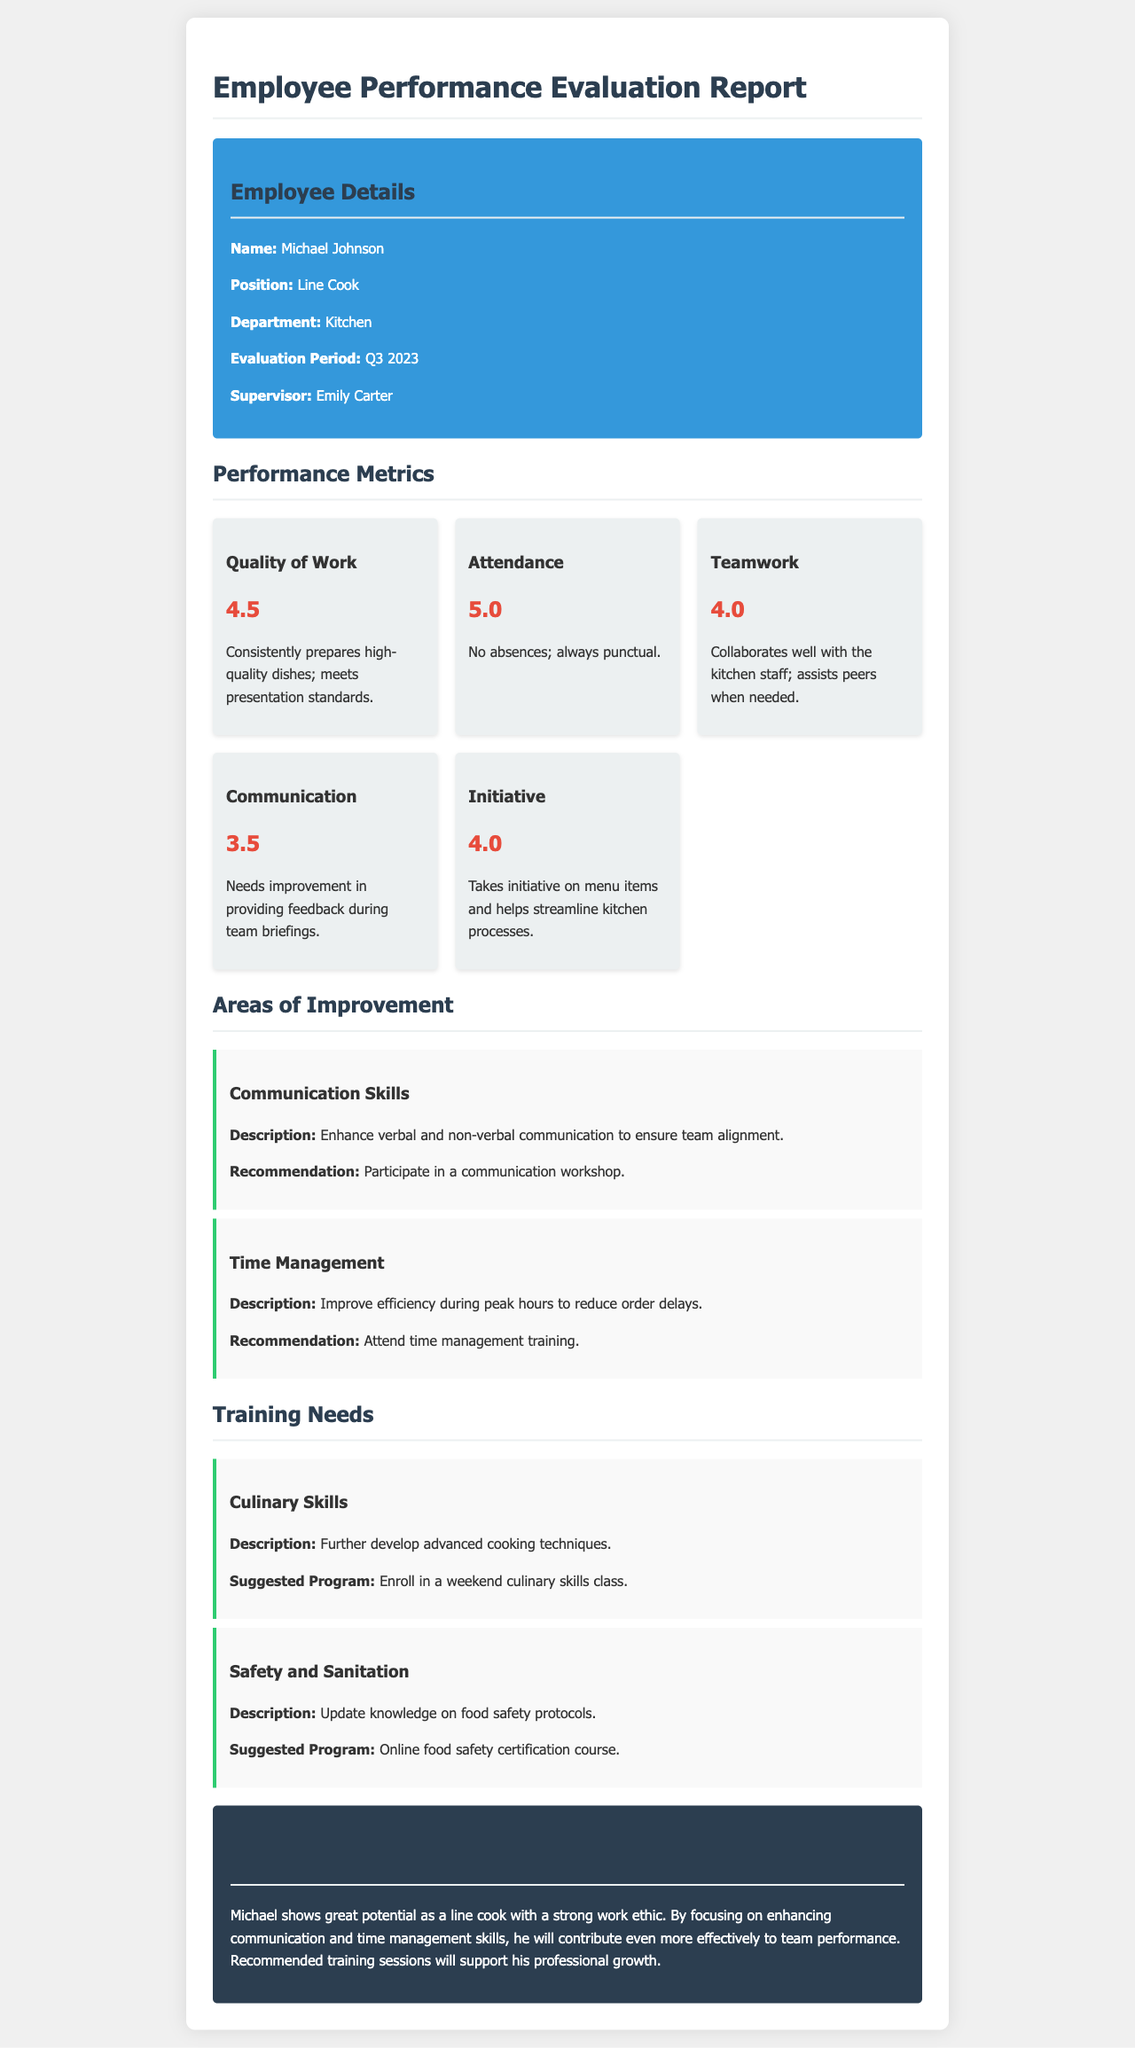What is the employee's name? The employee's name is listed in the "Employee Details" section of the document.
Answer: Michael Johnson What is the evaluation period? The evaluation period is specified under "Employee Details" of the report.
Answer: Q3 2023 What is the score for Attendance? Attendance performance is rated in the "Performance Metrics" section of the document.
Answer: 5.0 Which area needs improvement related to skills? The areas of improvement are indicated in their respective sections in the report.
Answer: Communication Skills What training program is suggested for Culinary Skills? The suggested program for training can be found under the "Training Needs" section.
Answer: Weekend culinary skills class How does Michael's score in Teamwork compare to Communication? This question requires comparison between two performance metrics mentioned in the report.
Answer: Teamwork: 4.0, Communication: 3.5 What is the overall assessment of Michael's performance? The overall evaluation summarizes his strengths and areas for development towards the end of the report.
Answer: Great potential as a line cook What recommendation is made for Time Management improvement? The recommendation is found in the "Areas of Improvement" section, detailing potential actions for enhancement.
Answer: Attend time management training Who is the supervisor mentioned in the document? The supervisor's name is provided in the "Employee Details" section.
Answer: Emily Carter 